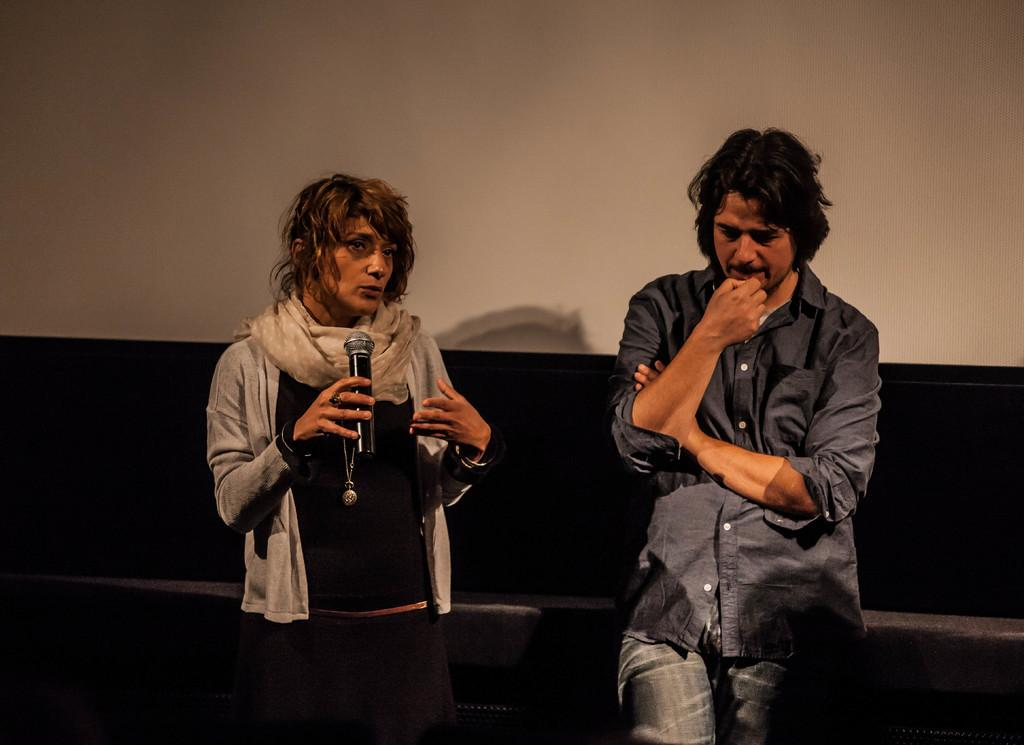Who are the people in the image? There is a woman and a man in the image. What is the woman holding in the image? The woman is holding a mic in the image. What is the woman wearing in the image? The woman is wearing a scarf in the image. What type of laborer is depicted in the image? There is no laborer depicted in the image; it features a woman holding a mic and a man. Where is the crib located in the image? There is no crib present in the image. 